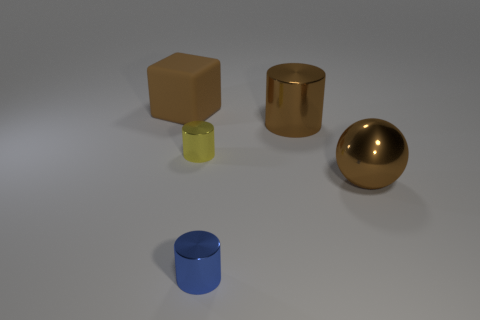What is the material of the large block?
Keep it short and to the point. Rubber. What number of large objects are either brown balls or red rubber objects?
Offer a very short reply. 1. How many objects are on the left side of the big rubber object?
Your answer should be compact. 0. Is there a large metallic object of the same color as the big block?
Offer a very short reply. Yes. There is a brown rubber thing that is the same size as the brown ball; what is its shape?
Offer a very short reply. Cube. How many brown things are either big cylinders or small objects?
Offer a very short reply. 1. What number of brown metal things are the same size as the sphere?
Your answer should be very brief. 1. There is a big shiny thing that is the same color as the sphere; what is its shape?
Ensure brevity in your answer.  Cylinder. How many objects are either big purple matte cylinders or small things on the right side of the tiny yellow cylinder?
Ensure brevity in your answer.  1. Does the brown shiny thing in front of the large cylinder have the same size as the thing left of the tiny yellow object?
Ensure brevity in your answer.  Yes. 